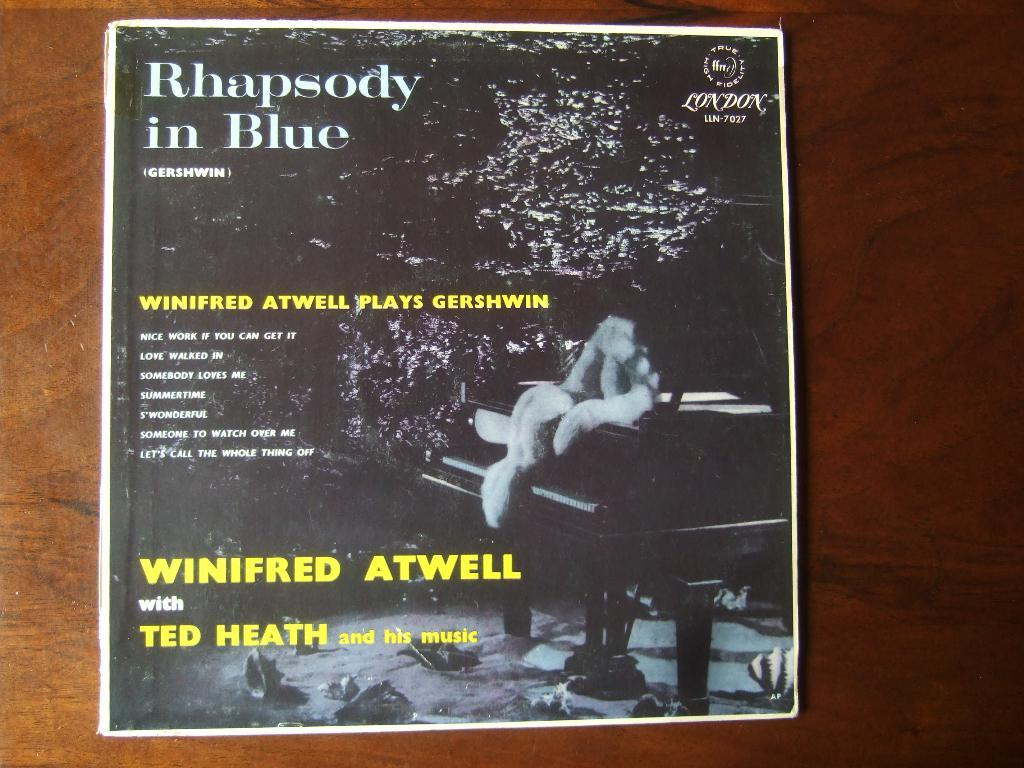<image>
Give a short and clear explanation of the subsequent image. The album cover Rhapsody in Blue by Winifred Atwell. 